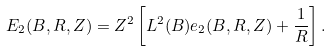Convert formula to latex. <formula><loc_0><loc_0><loc_500><loc_500>E _ { 2 } ( B , R , Z ) = Z ^ { 2 } \left [ L ^ { 2 } ( B ) e _ { 2 } ( B , R , Z ) + \frac { 1 } { R } \right ] .</formula> 